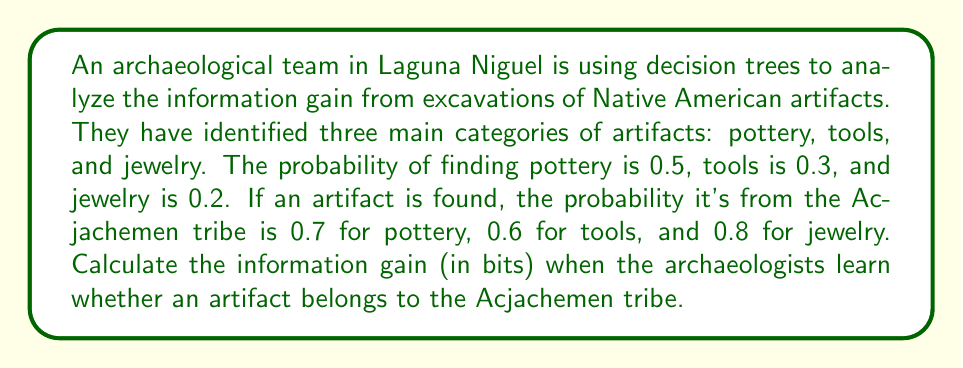Can you solve this math problem? To solve this problem, we need to use the concept of information gain from decision trees in information theory. We'll follow these steps:

1. Calculate the entropy of the artifact types (before knowing the tribe):
   $$H(Artifact) = -\sum_{i} p(i) \log_2(p(i))$$
   where $i$ represents each artifact type.

2. Calculate the entropy of the artifact types given the tribe information:
   $$H(Artifact|Tribe) = \sum_{j} p(j) \cdot (-\sum_{i} p(i|j) \log_2(p(i|j)))$$
   where $j$ represents whether it belongs to the Acjachemen tribe or not.

3. Calculate the information gain:
   $$IG = H(Artifact) - H(Artifact|Tribe)$$

Step 1: Entropy of artifact types
$$H(Artifact) = -[0.5 \log_2(0.5) + 0.3 \log_2(0.3) + 0.2 \log_2(0.2)]$$
$$H(Artifact) = 1.4855 \text{ bits}$$

Step 2: Entropy given tribe information
First, we need to calculate $p(Acjachemen)$:
$$p(Acjachemen) = 0.5 \cdot 0.7 + 0.3 \cdot 0.6 + 0.2 \cdot 0.8 = 0.69$$

Now we can calculate $H(Artifact|Tribe)$:

For Acjachemen:
$$p(pottery|Acjachemen) = \frac{0.5 \cdot 0.7}{0.69} = 0.5072$$
$$p(tools|Acjachemen) = \frac{0.3 \cdot 0.6}{0.69} = 0.2609$$
$$p(jewelry|Acjachemen) = \frac{0.2 \cdot 0.8}{0.69} = 0.2319$$

For non-Acjachemen:
$$p(pottery|non-Acjachemen) = \frac{0.5 \cdot 0.3}{0.31} = 0.4839$$
$$p(tools|non-Acjachemen) = \frac{0.3 \cdot 0.4}{0.31} = 0.3871$$
$$p(jewelry|non-Acjachemen) = \frac{0.2 \cdot 0.2}{0.31} = 0.1290$$

$$H(Artifact|Tribe) = 0.69 \cdot (-0.5072 \log_2(0.5072) - 0.2609 \log_2(0.2609) - 0.2319 \log_2(0.2319))$$
$$+ 0.31 \cdot (-0.4839 \log_2(0.4839) - 0.3871 \log_2(0.3871) - 0.1290 \log_2(0.1290))$$
$$H(Artifact|Tribe) = 1.4590 \text{ bits}$$

Step 3: Information gain
$$IG = H(Artifact) - H(Artifact|Tribe)$$
$$IG = 1.4855 - 1.4590 = 0.0265 \text{ bits}$$
Answer: The information gain when the archaeologists learn whether an artifact belongs to the Acjachemen tribe is 0.0265 bits. 